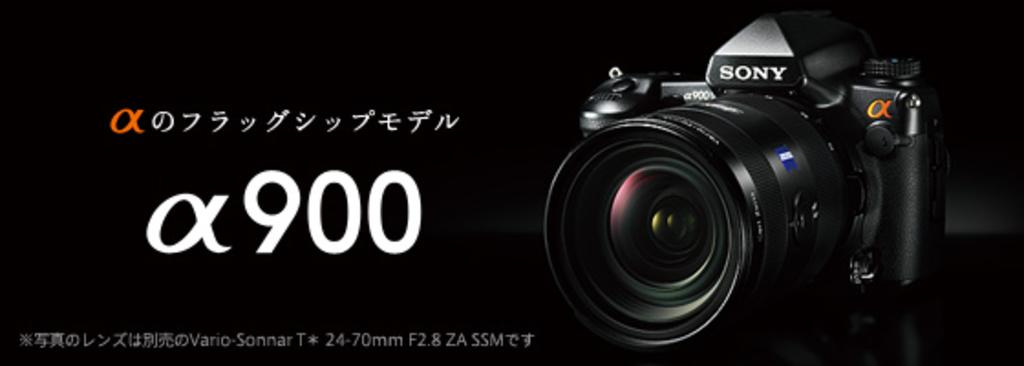What is the main object in the picture? There is a camera in the picture. What can be found on the left side of the picture? There is text and numbers on the left side of the picture. How would you describe the overall lighting in the image? The background of the image is dark. What type of joke is being told by the camera in the image? There is no joke being told by the camera in the image, as cameras do not have the ability to tell jokes. 